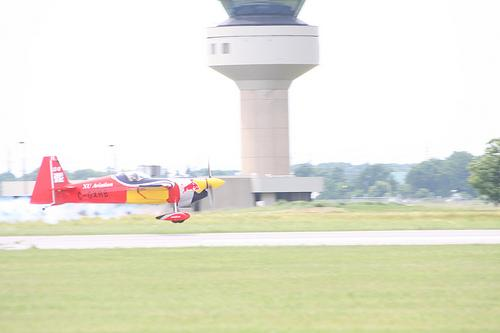Briefly describe the main subject and where it is located. A small older red and yellow airplane is taking off from a runway near a control tower. Mention the color and type of the aircraft along with its position in relation to the ground. The red and yellow small single passenger airplane is in the air above the runway. Recount the main object's appearance, location, and environment. The red and yellow airplane is taking off above a landing strip with a control tower and green field at the airport. Depict the central focus of the image in a single sentence. A small red and yellow airplane is soaring into the sky during daytime above a runway at an airport. Provide a brief description of the main object in the image and its action. A red and yellow airplane is taking off from the runway while in motion. Summarize the location and environment surrounding the primary object in the image. The airplane is at an airport with a control tower, green grass, and trees in the background. Explain the scene happening with the aircraft and its surroundings. The red and yellow airplane is in the air, taking off over a narrow landing strip with green grass and a control tower behind it. Illustrate the image by highlighting the relation between the airplane and the runway. A red and yellow airplane is taking flight over the runway, surrounded by green grass and trees at an airport. Describe the airplane and its position to the control tower. A red and yellow airplane is near a round airport communication tower, taking off. Write a sentence about the plane's design and motion. The plane has identifying decals and a yellow propeller, and is in motion as it takes off. 